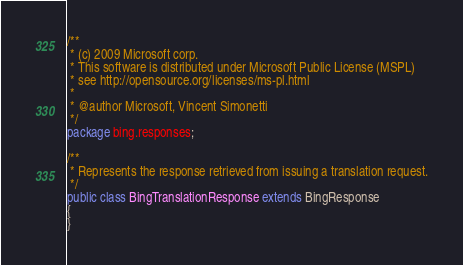<code> <loc_0><loc_0><loc_500><loc_500><_Java_>/**
 * (c) 2009 Microsoft corp.
 * This software is distributed under Microsoft Public License (MSPL)
 * see http://opensource.org/licenses/ms-pl.html
 * 
 * @author Microsoft, Vincent Simonetti
 */
package bing.responses;

/**
 * Represents the response retrieved from issuing a translation request.
 */
public class BingTranslationResponse extends BingResponse
{
}
</code> 